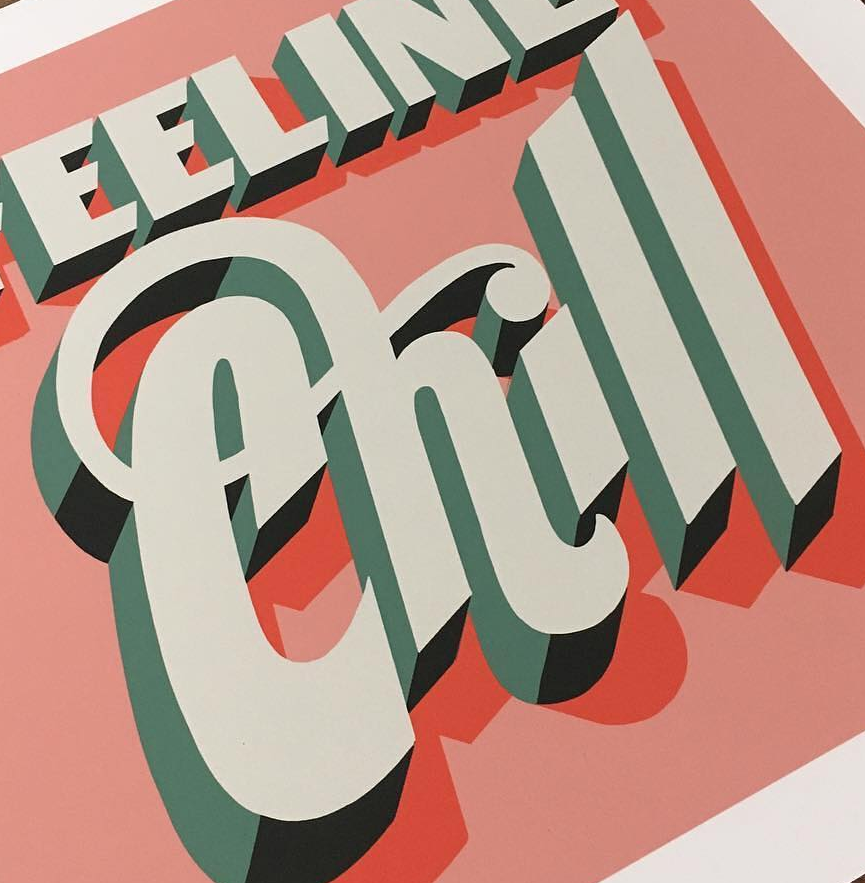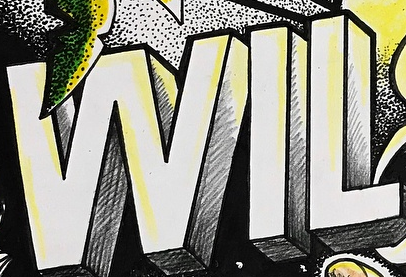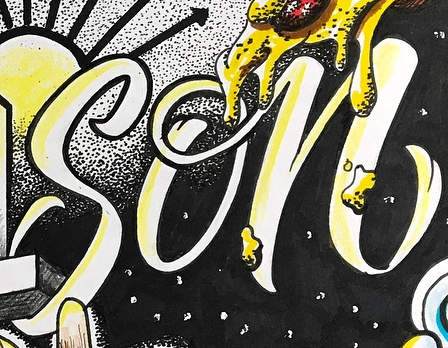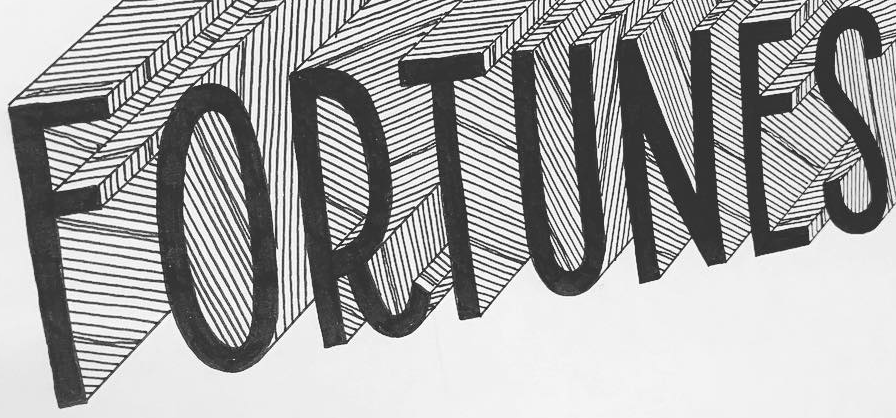Read the text content from these images in order, separated by a semicolon. Chill; WIL; son; FORTUNES 